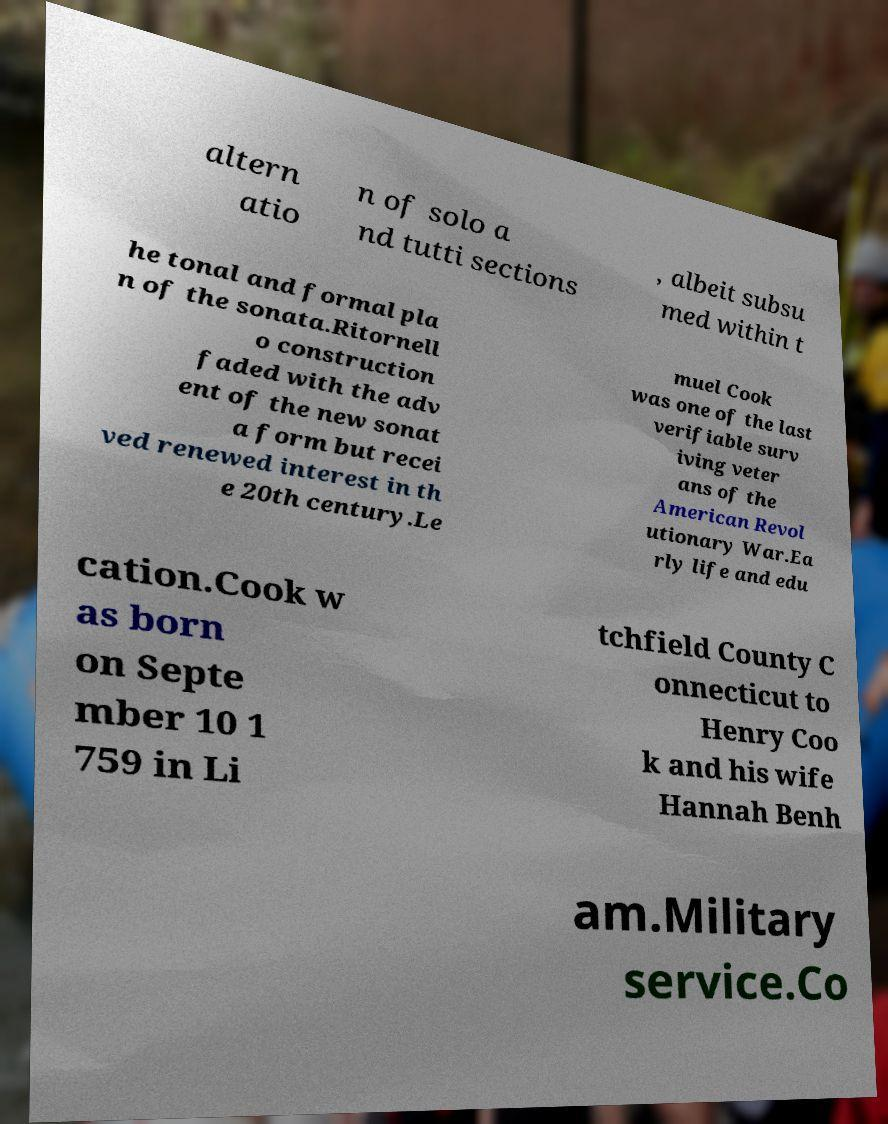There's text embedded in this image that I need extracted. Can you transcribe it verbatim? altern atio n of solo a nd tutti sections , albeit subsu med within t he tonal and formal pla n of the sonata.Ritornell o construction faded with the adv ent of the new sonat a form but recei ved renewed interest in th e 20th century.Le muel Cook was one of the last verifiable surv iving veter ans of the American Revol utionary War.Ea rly life and edu cation.Cook w as born on Septe mber 10 1 759 in Li tchfield County C onnecticut to Henry Coo k and his wife Hannah Benh am.Military service.Co 